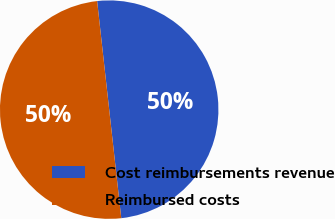Convert chart to OTSL. <chart><loc_0><loc_0><loc_500><loc_500><pie_chart><fcel>Cost reimbursements revenue<fcel>Reimbursed costs<nl><fcel>50.0%<fcel>50.0%<nl></chart> 